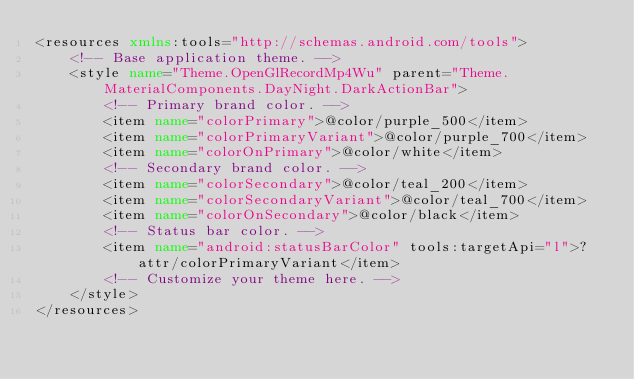<code> <loc_0><loc_0><loc_500><loc_500><_XML_><resources xmlns:tools="http://schemas.android.com/tools">
    <!-- Base application theme. -->
    <style name="Theme.OpenGlRecordMp4Wu" parent="Theme.MaterialComponents.DayNight.DarkActionBar">
        <!-- Primary brand color. -->
        <item name="colorPrimary">@color/purple_500</item>
        <item name="colorPrimaryVariant">@color/purple_700</item>
        <item name="colorOnPrimary">@color/white</item>
        <!-- Secondary brand color. -->
        <item name="colorSecondary">@color/teal_200</item>
        <item name="colorSecondaryVariant">@color/teal_700</item>
        <item name="colorOnSecondary">@color/black</item>
        <!-- Status bar color. -->
        <item name="android:statusBarColor" tools:targetApi="l">?attr/colorPrimaryVariant</item>
        <!-- Customize your theme here. -->
    </style>
</resources></code> 